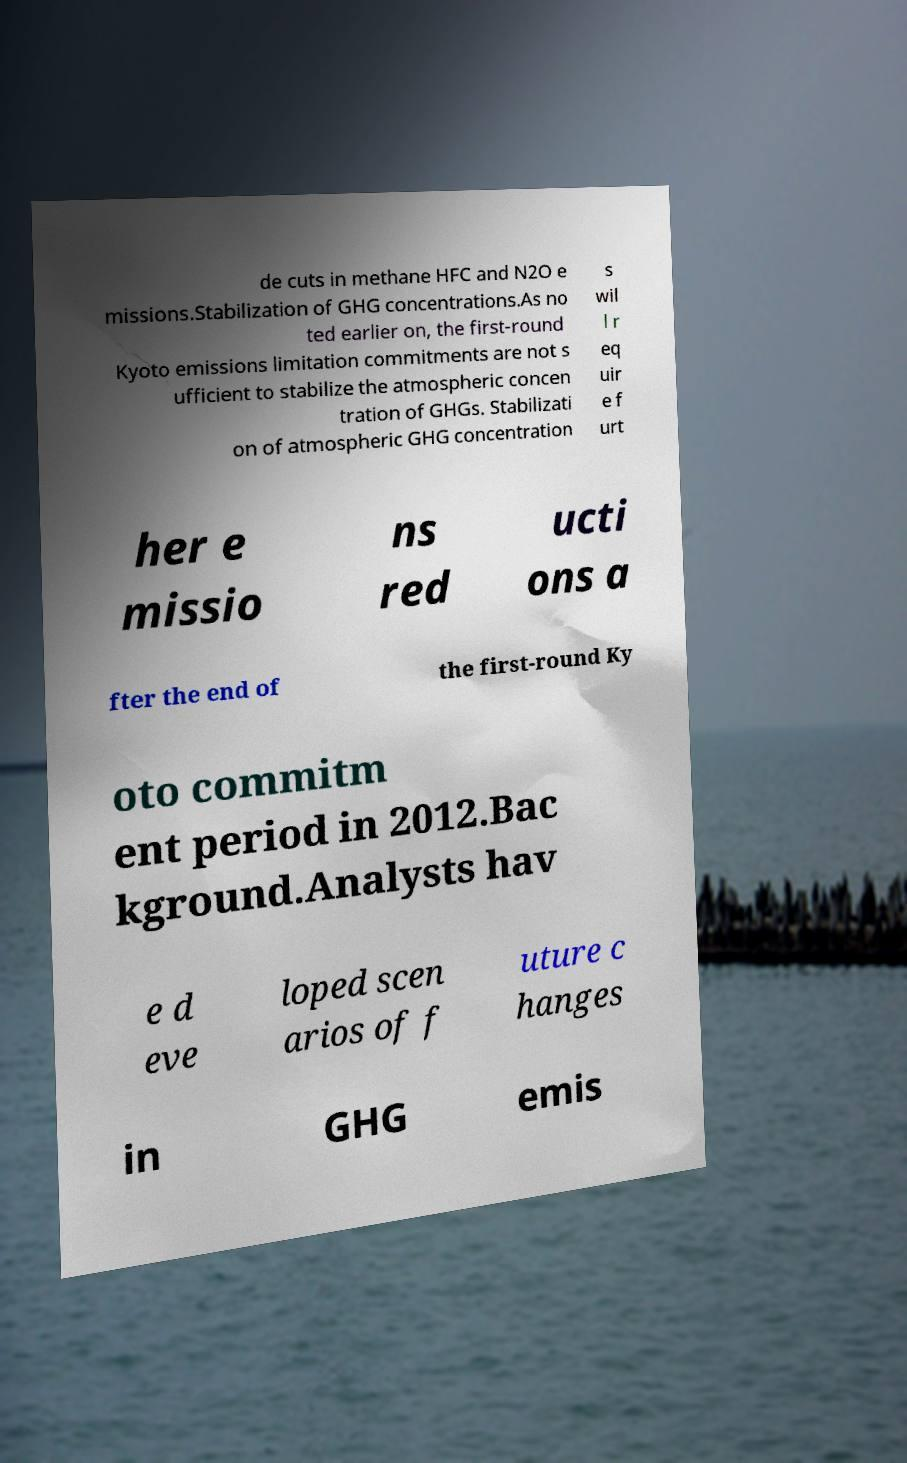Please read and relay the text visible in this image. What does it say? de cuts in methane HFC and N2O e missions.Stabilization of GHG concentrations.As no ted earlier on, the first-round Kyoto emissions limitation commitments are not s ufficient to stabilize the atmospheric concen tration of GHGs. Stabilizati on of atmospheric GHG concentration s wil l r eq uir e f urt her e missio ns red ucti ons a fter the end of the first-round Ky oto commitm ent period in 2012.Bac kground.Analysts hav e d eve loped scen arios of f uture c hanges in GHG emis 